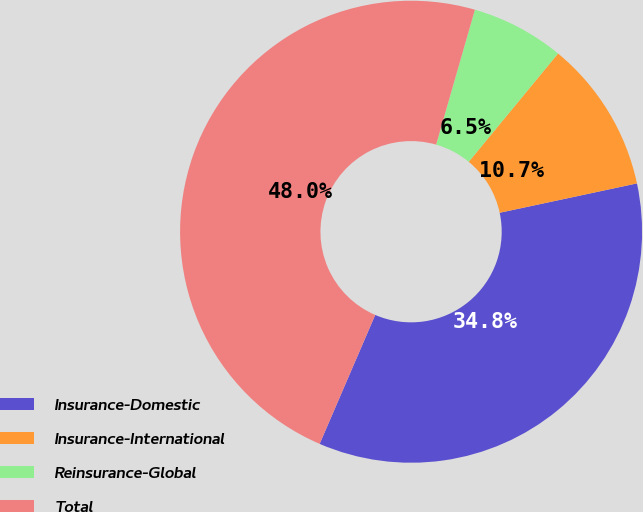Convert chart to OTSL. <chart><loc_0><loc_0><loc_500><loc_500><pie_chart><fcel>Insurance-Domestic<fcel>Insurance-International<fcel>Reinsurance-Global<fcel>Total<nl><fcel>34.83%<fcel>10.67%<fcel>6.52%<fcel>47.98%<nl></chart> 